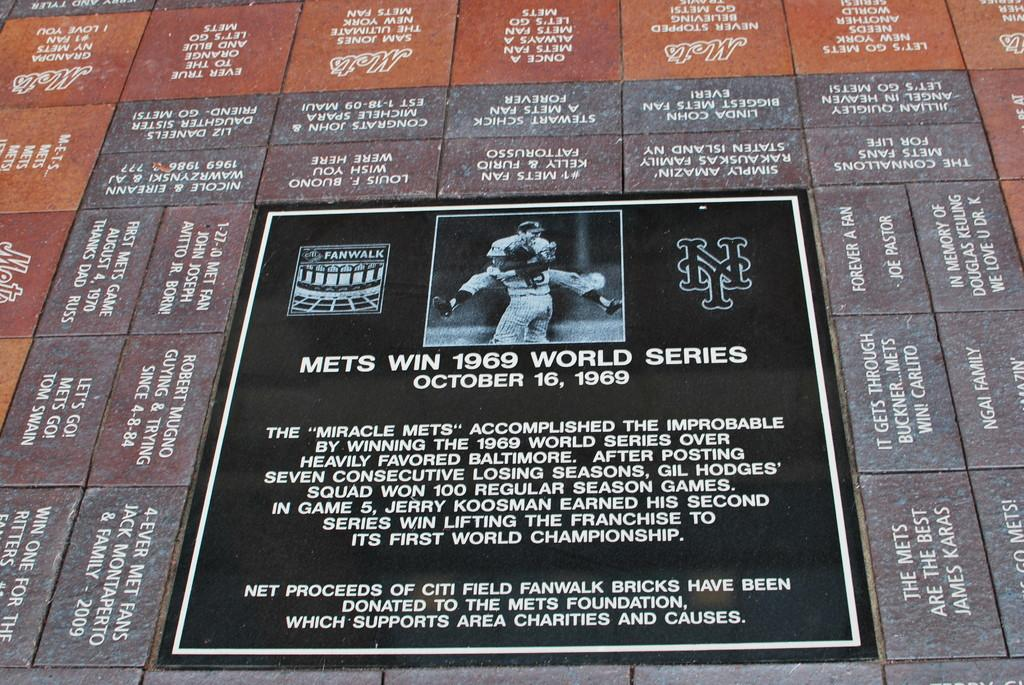<image>
Render a clear and concise summary of the photo. Poster which shows the Mets winning the World Series in 1969. 